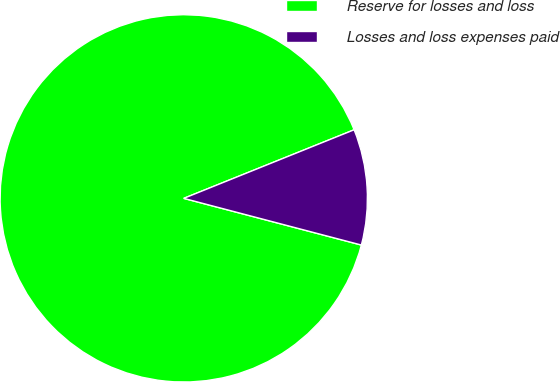<chart> <loc_0><loc_0><loc_500><loc_500><pie_chart><fcel>Reserve for losses and loss<fcel>Losses and loss expenses paid<nl><fcel>89.82%<fcel>10.18%<nl></chart> 